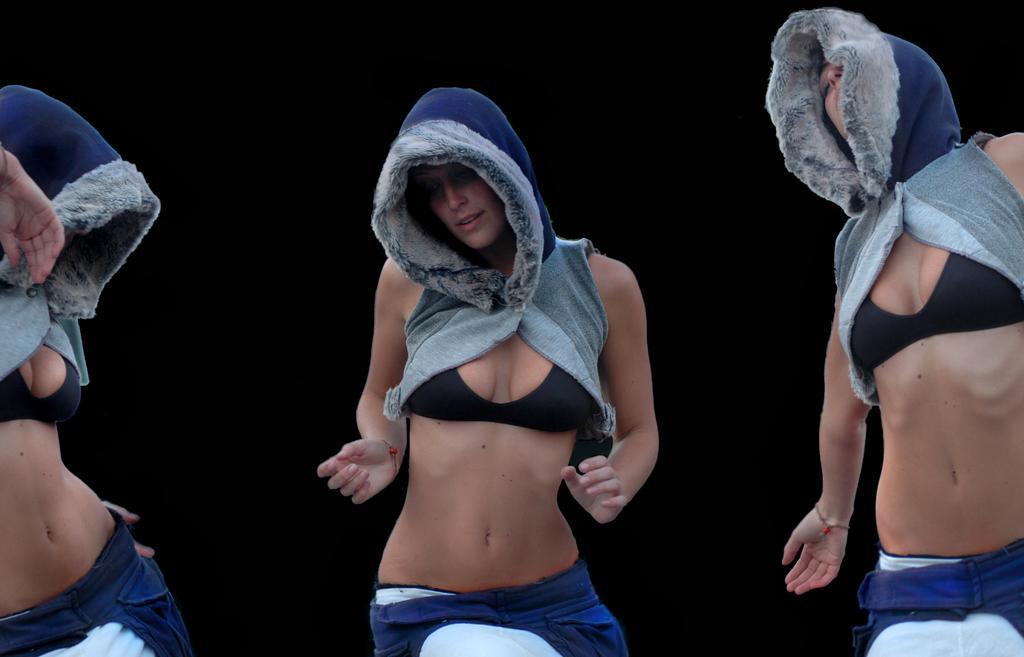How would you summarize this image in a sentence or two? In this image we can see there are people dancing and there is a dark background. 